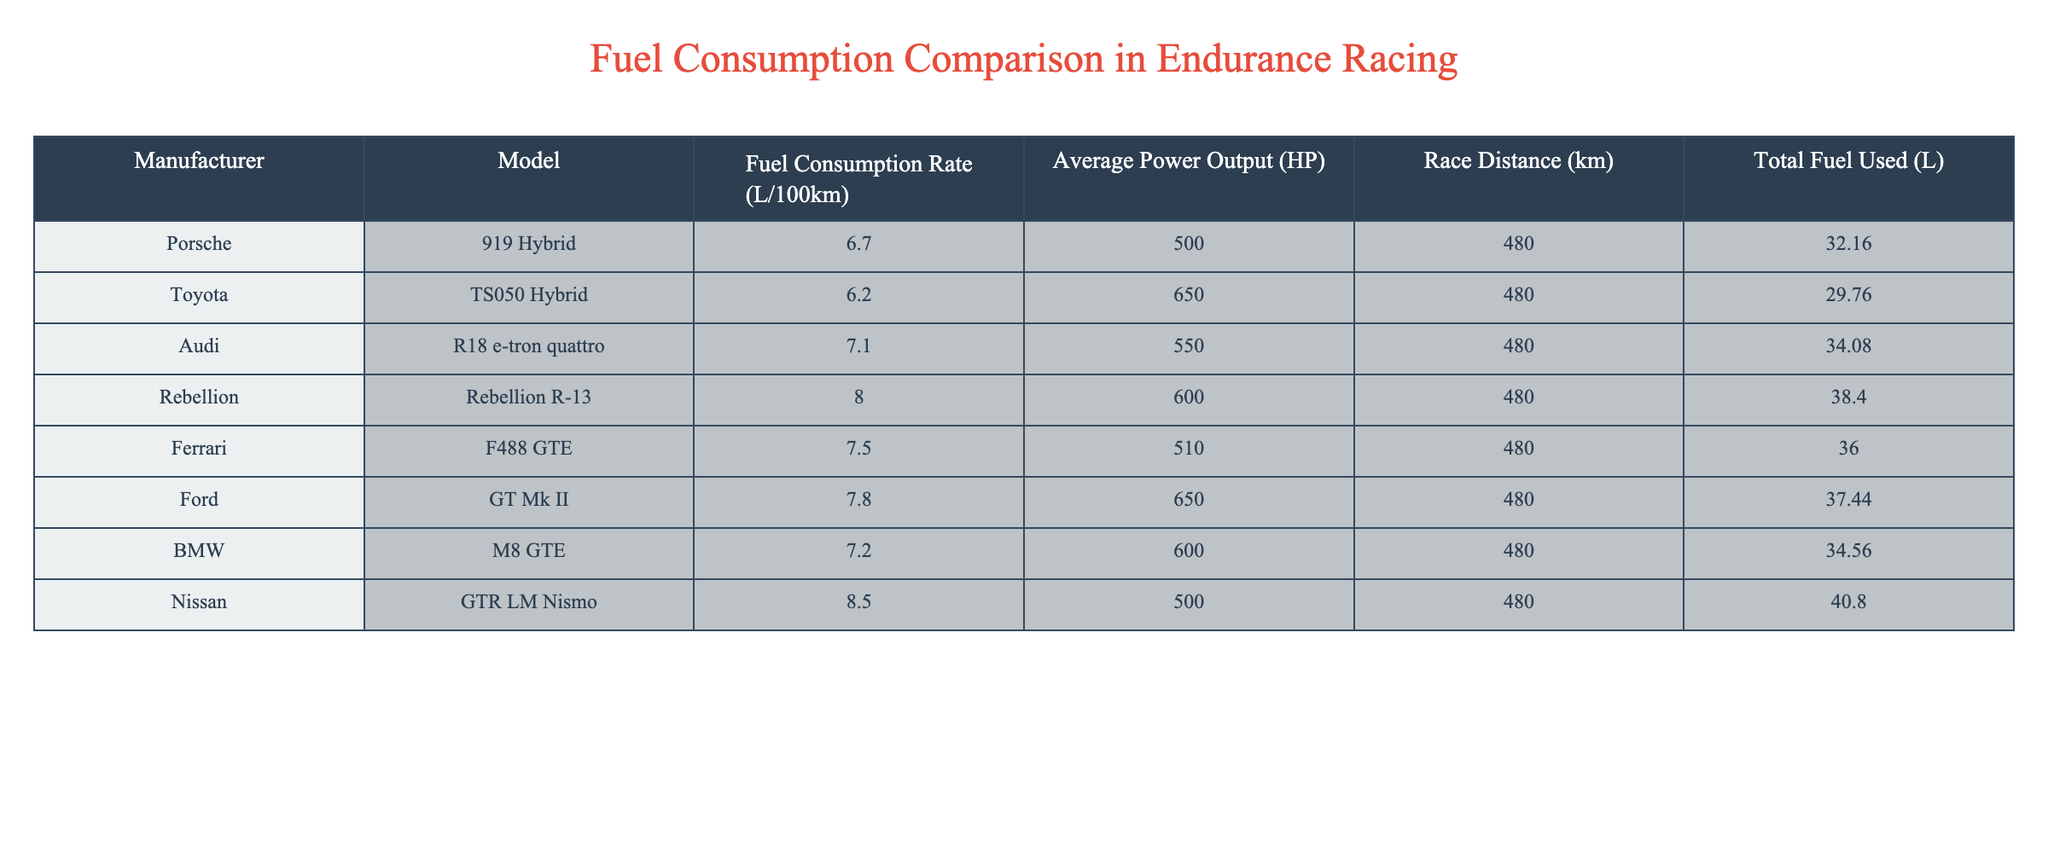What is the fuel consumption rate of the Toyota TS050 Hybrid? The fuel consumption rate of the Toyota TS050 Hybrid is listed directly in the table. It shows that the fuel consumption rate for this model is 6.2 L/100km.
Answer: 6.2 L/100km Which manufacturer has the highest total fuel used in the race? By examining the Total Fuel Used column in the table, we can identify the maximum value. The Rebellion R-13 has the highest total fuel used, which is 38.40 L.
Answer: Rebellion R-13 What is the average fuel consumption rate of Audi and BMW? To find the average, add the fuel consumption rates of Audi (7.1 L/100km) and BMW (7.2 L/100km), which totals 14.3 L/100km. Then, divide by 2 (since there are two values). Thus, the average is 14.3 L/100km / 2 = 7.15 L/100km.
Answer: 7.15 L/100km Does the Ford GT Mk II have a higher fuel consumption rate than the Porsche 919 Hybrid? Comparing the rates in the table, the Ford GT Mk II has a fuel consumption rate of 7.8 L/100km, while the Porsche 919 Hybrid has a rate of 6.7 L/100km. Since 7.8 is greater than 6.7, the Ford does have a higher rate.
Answer: Yes What is the total fuel used by Nissan GTR LM Nismo and Ferrari F488 GTE combined? To find the combined total fuel used, add the total fuel used for Nissan (40.80 L) and Ferrari (36.00 L). The sum is 40.80 L + 36.00 L = 76.80 L.
Answer: 76.80 L Which model has the lowest average power output, and what is that power? The average power output is listed for each model. By looking at the Power Output column, the Porsche 919 Hybrid has the lowest value of 500 HP among the entries.
Answer: Porsche 919 Hybrid, 500 HP What is the difference in fuel consumption between the highest and lowest rates? The highest fuel consumption rate is 8.5 L/100km for the Nissan GTR LM Nismo, and the lowest is 6.2 L/100km for the Toyota TS050 Hybrid. The difference is 8.5 - 6.2 = 2.3 L/100km.
Answer: 2.3 L/100km Are there any models with a fuel consumption rate over 8 L/100km? By reviewing the Fuel Consumption Rate column, the Rebellion R-13 (8.0 L/100km) and Nissan GTR LM Nismo (8.5 L/100km) both exceed 8 L/100km. Therefore, the answer is yes.
Answer: Yes 